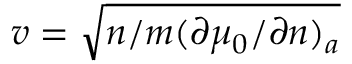<formula> <loc_0><loc_0><loc_500><loc_500>v = \sqrt { n / m ( \partial \mu _ { 0 } / \partial n ) _ { a } }</formula> 